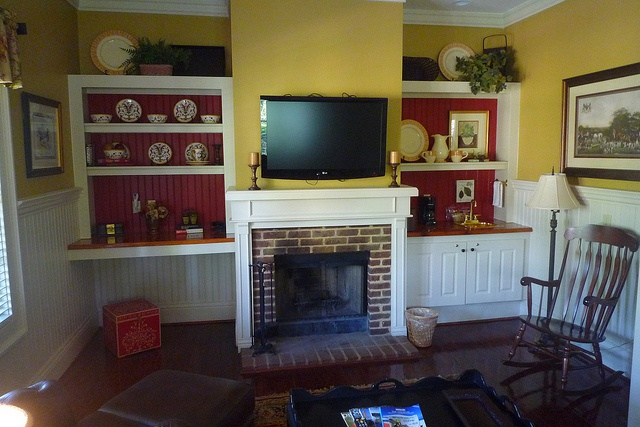Describe the objects in this image and their specific colors. I can see chair in black, gray, and darkgray tones, tv in black and teal tones, couch in black, maroon, and white tones, potted plant in black, darkgreen, olive, and gray tones, and potted plant in black, maroon, darkgreen, and gray tones in this image. 